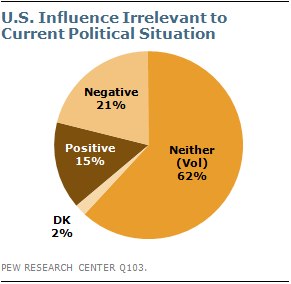Mention a couple of crucial points in this snapshot. The second largest segment in the image has a ratio of 1.4 times the positive segment. 